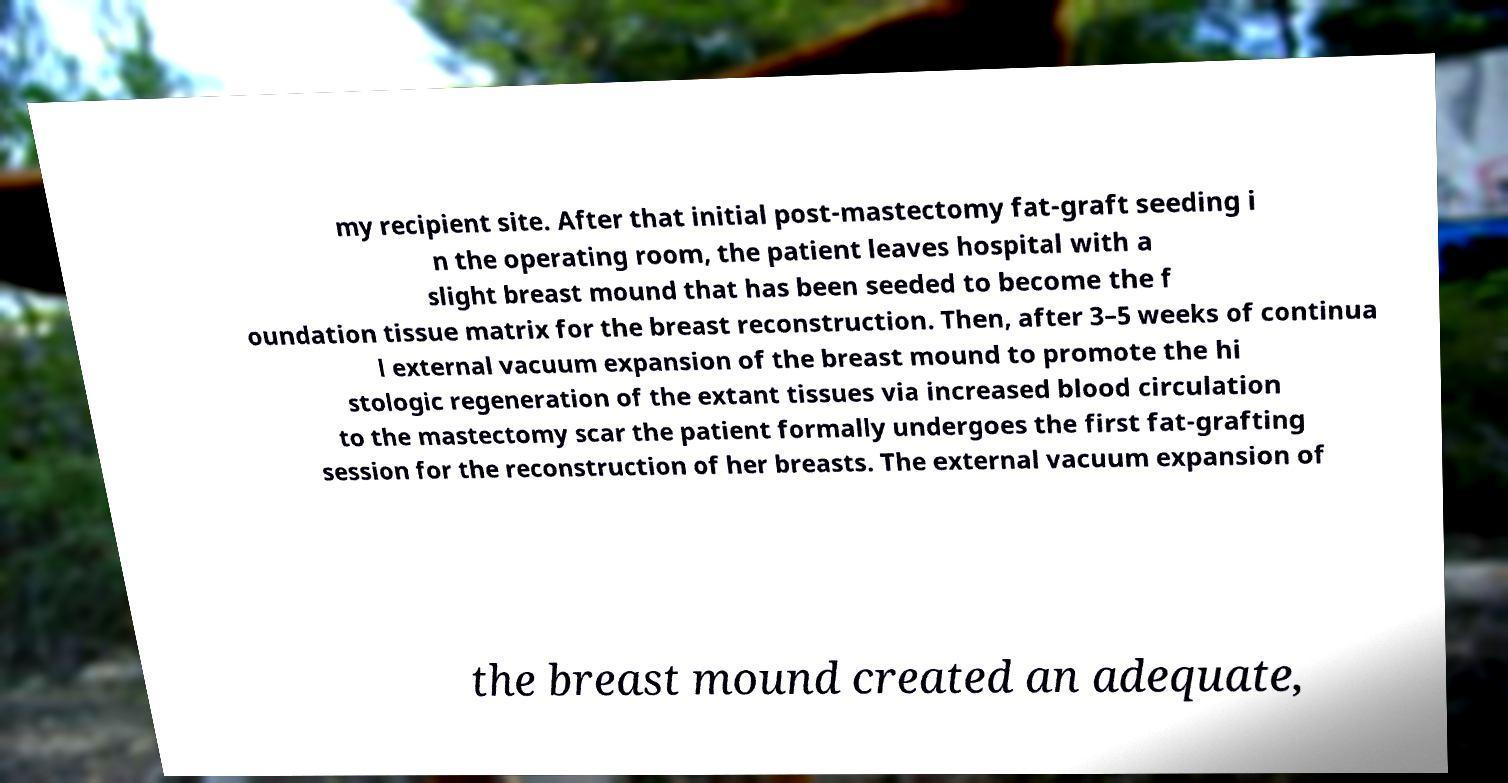Can you accurately transcribe the text from the provided image for me? my recipient site. After that initial post-mastectomy fat-graft seeding i n the operating room, the patient leaves hospital with a slight breast mound that has been seeded to become the f oundation tissue matrix for the breast reconstruction. Then, after 3–5 weeks of continua l external vacuum expansion of the breast mound to promote the hi stologic regeneration of the extant tissues via increased blood circulation to the mastectomy scar the patient formally undergoes the first fat-grafting session for the reconstruction of her breasts. The external vacuum expansion of the breast mound created an adequate, 